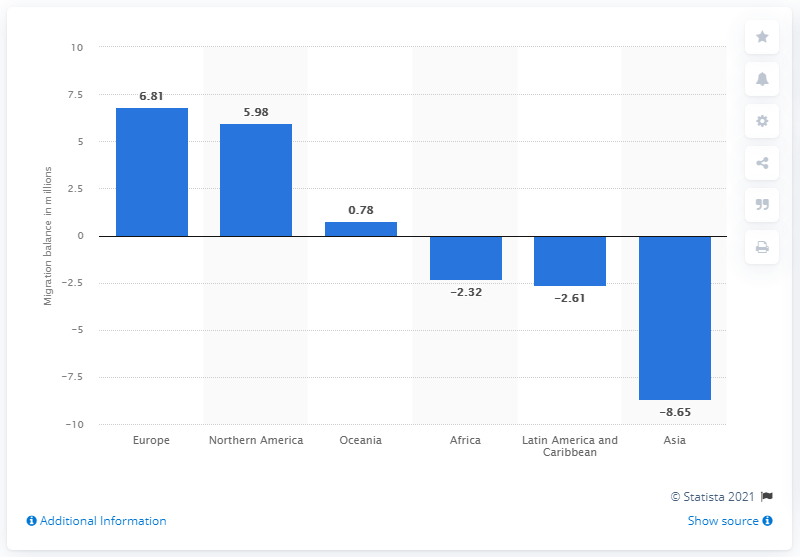Mention a couple of crucial points in this snapshot. According to estimates, the number of people who are expected to immigrate to Europe between 2015 and 2020 is 6.81 million. 